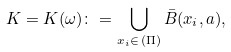<formula> <loc_0><loc_0><loc_500><loc_500>K = K ( \omega ) \colon = \bigcup _ { x _ { i } \in \, ( \Pi ) } \bar { B } ( x _ { i } , a ) ,</formula> 